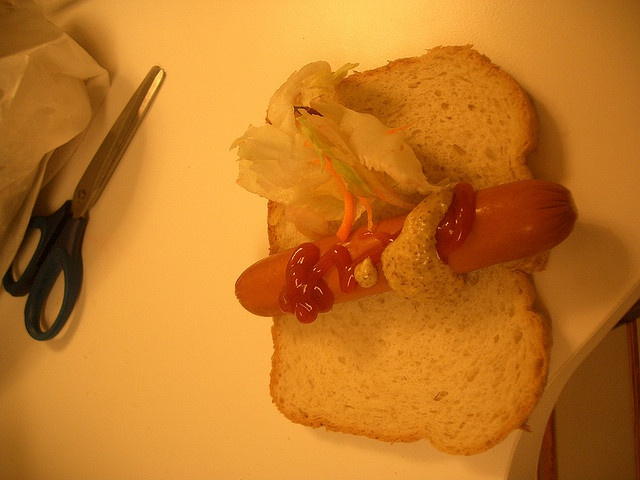Describe the objects in this image and their specific colors. I can see sandwich in maroon, orange, and red tones, hot dog in maroon, brown, and red tones, and scissors in maroon, black, and brown tones in this image. 